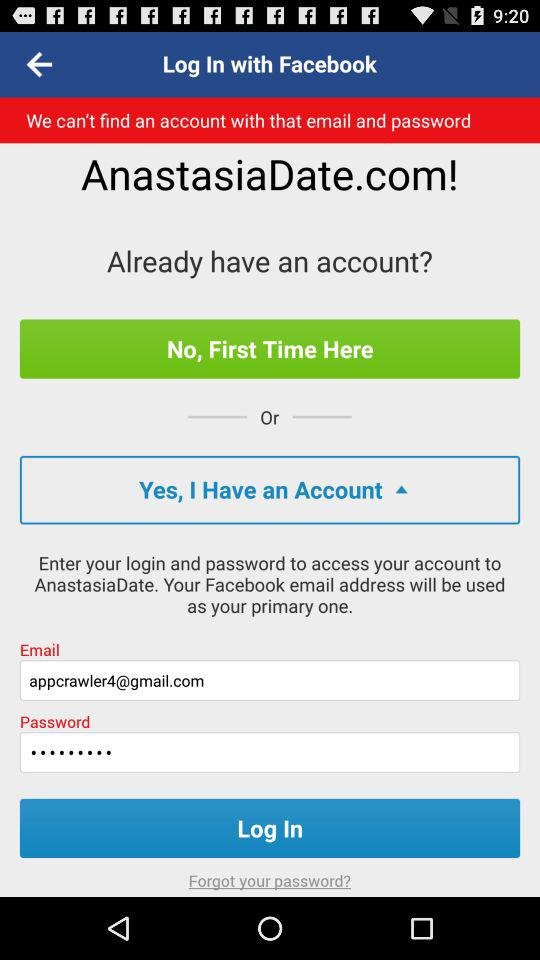What is the email address? The email address is appcrawler4@gmail.com. 